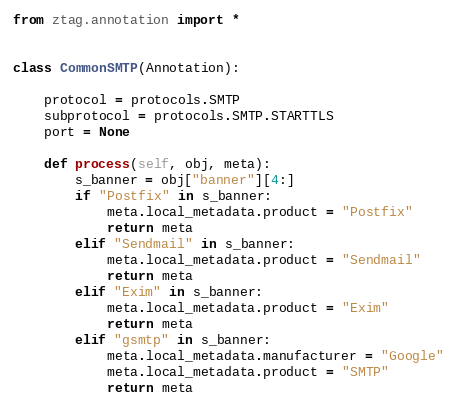<code> <loc_0><loc_0><loc_500><loc_500><_Python_>from ztag.annotation import *


class CommonSMTP(Annotation):

    protocol = protocols.SMTP
    subprotocol = protocols.SMTP.STARTTLS
    port = None

    def process(self, obj, meta):
        s_banner = obj["banner"][4:]
        if "Postfix" in s_banner:
            meta.local_metadata.product = "Postfix"
            return meta
        elif "Sendmail" in s_banner:
            meta.local_metadata.product = "Sendmail"
            return meta
        elif "Exim" in s_banner:
            meta.local_metadata.product = "Exim"
            return meta
        elif "gsmtp" in s_banner:
            meta.local_metadata.manufacturer = "Google"
            meta.local_metadata.product = "SMTP"
            return meta

</code> 